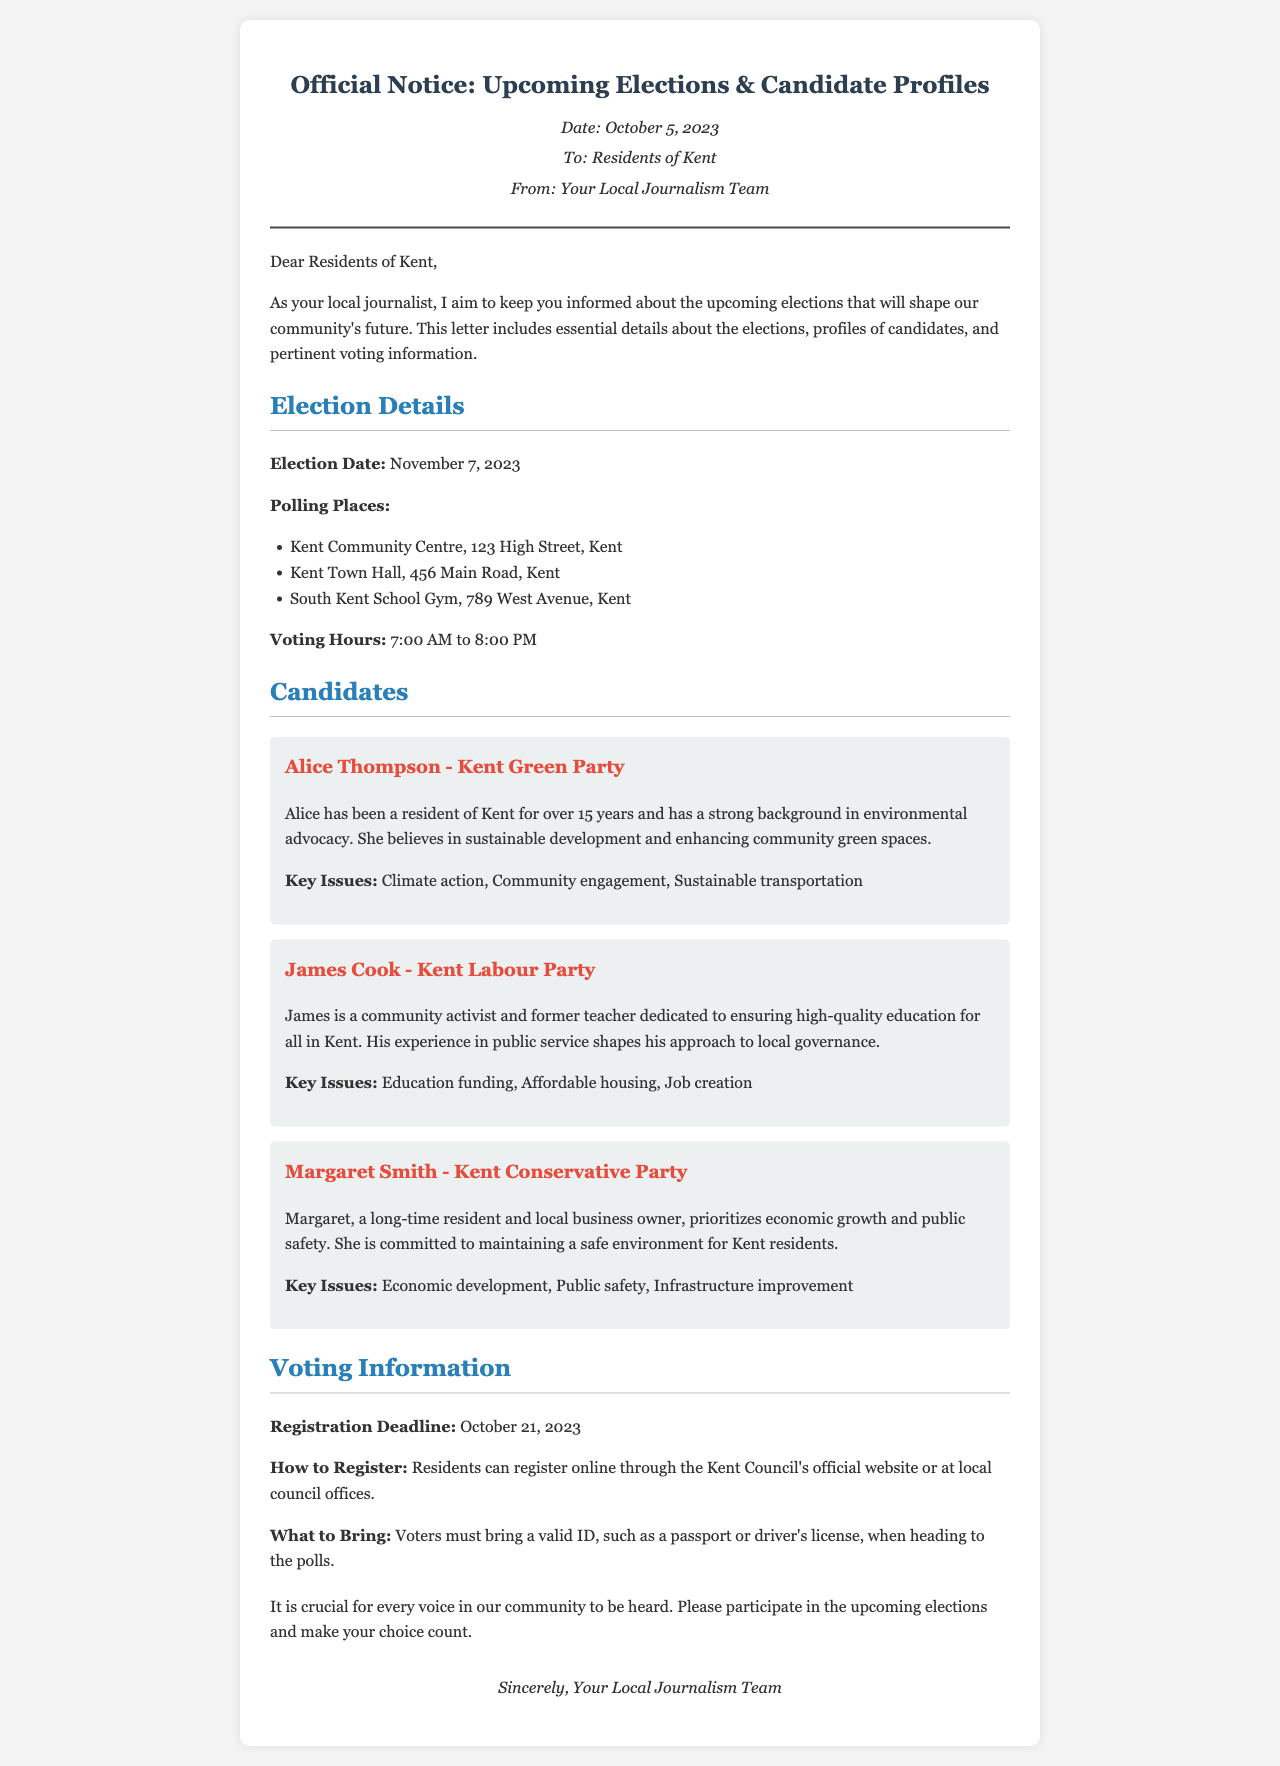What is the election date? The election date is explicitly stated in the document.
Answer: November 7, 2023 What are the polling places? The document lists three locations where polling will occur.
Answer: Kent Community Centre, Kent Town Hall, South Kent School Gym Who is the candidate from the Kent Green Party? The candidate representing the Kent Green Party is mentioned in the candidates section.
Answer: Alice Thompson What is the registration deadline? The document provides information on when residents need to register by.
Answer: October 21, 2023 What is one of Margaret Smith's key issues? The document outlines the top concerns for each candidate, including Margaret Smith's.
Answer: Economic development Why should residents participate in the elections? The document emphasizes the importance of community involvement in elections.
Answer: To have their voices heard How can residents register to vote? The document includes details regarding the registration process.
Answer: Online through the Kent Council's official website or at local council offices What must voters bring to the polls? The document specifies the identification required when voting.
Answer: A valid ID, such as a passport or driver's license What time do polls open? The document outlines the voting hours on election day.
Answer: 7:00 AM 